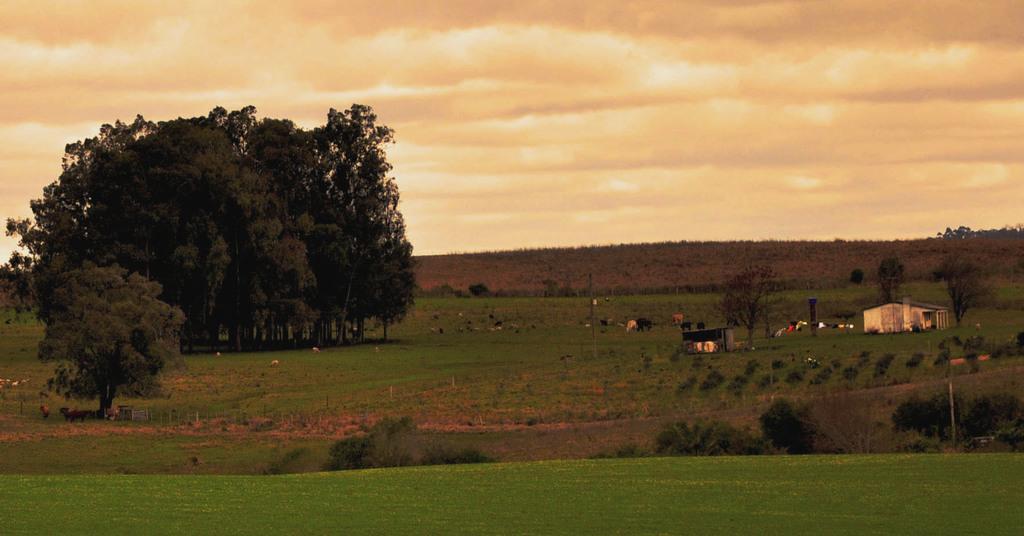In one or two sentences, can you explain what this image depicts? In this image, we can see trees, sheds, poles and we can see some clothes which are hanging and we can see some animals. At the bottom, there is ground and at the top, there is sky. 